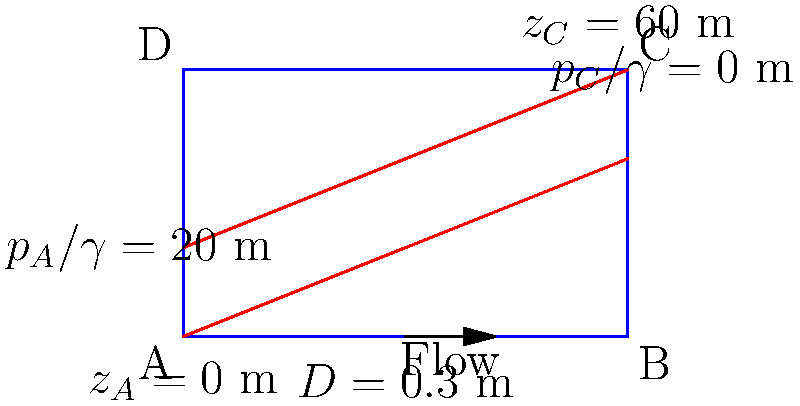Imagine you're designing a water supply system for the West Ham United training ground, inspired by Mark Noble's dedication to the team. In this pipe network, water flows from point A to point C. Given that the pipe diameter is 0.3 m, the length of the pipe is 100 m, and the Darcy-Weisbach friction factor is 0.02, calculate the flow rate in the pipe using the hydraulic grade line information provided in the diagram. Assume the kinematic viscosity of water is $1 \times 10^{-6}$ m²/s. Let's approach this step-by-step, just like Mark Noble would methodically analyze a play:

1) First, we need to calculate the total head loss between points A and C using the hydraulic grade line information:

   Total head loss = $(z_C + \frac{p_C}{\gamma}) - (z_A + \frac{p_A}{\gamma})$
                   = $(60 + 0) - (0 + 20) = 40$ m

2) Now, we can use the Darcy-Weisbach equation to relate this head loss to the flow rate:

   $h_f = f \frac{L}{D} \frac{V^2}{2g}$

   Where:
   $h_f$ = head loss (40 m)
   $f$ = Darcy-Weisbach friction factor (0.02)
   $L$ = pipe length (100 m)
   $D$ = pipe diameter (0.3 m)
   $V$ = flow velocity (unknown)
   $g$ = acceleration due to gravity (9.81 m/s²)

3) Rearranging the equation to solve for velocity:

   $V = \sqrt{\frac{2gh_fD}{fL}} = \sqrt{\frac{2 \cdot 9.81 \cdot 40 \cdot 0.3}{0.02 \cdot 100}} = 7.67$ m/s

4) Now that we have the velocity, we can calculate the flow rate:

   $Q = AV = \frac{\pi D^2}{4} V = \frac{\pi \cdot 0.3^2}{4} \cdot 7.67 = 0.542$ m³/s

5) To verify our solution, we can check the Reynolds number:

   $Re = \frac{VD}{\nu} = \frac{7.67 \cdot 0.3}{1 \times 10^{-6}} = 2,301,000$

   This high Reynolds number confirms turbulent flow, consistent with our use of the Darcy-Weisbach equation.
Answer: 0.542 m³/s 